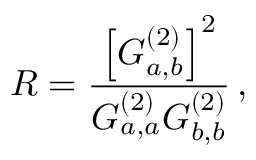<formula> <loc_0><loc_0><loc_500><loc_500>R = \frac { \left [ G _ { a , b } ^ { ( 2 ) } \right ] ^ { 2 } } { G _ { a , a } ^ { ( 2 ) } G _ { b , b } ^ { ( 2 ) } } \, ,</formula> 